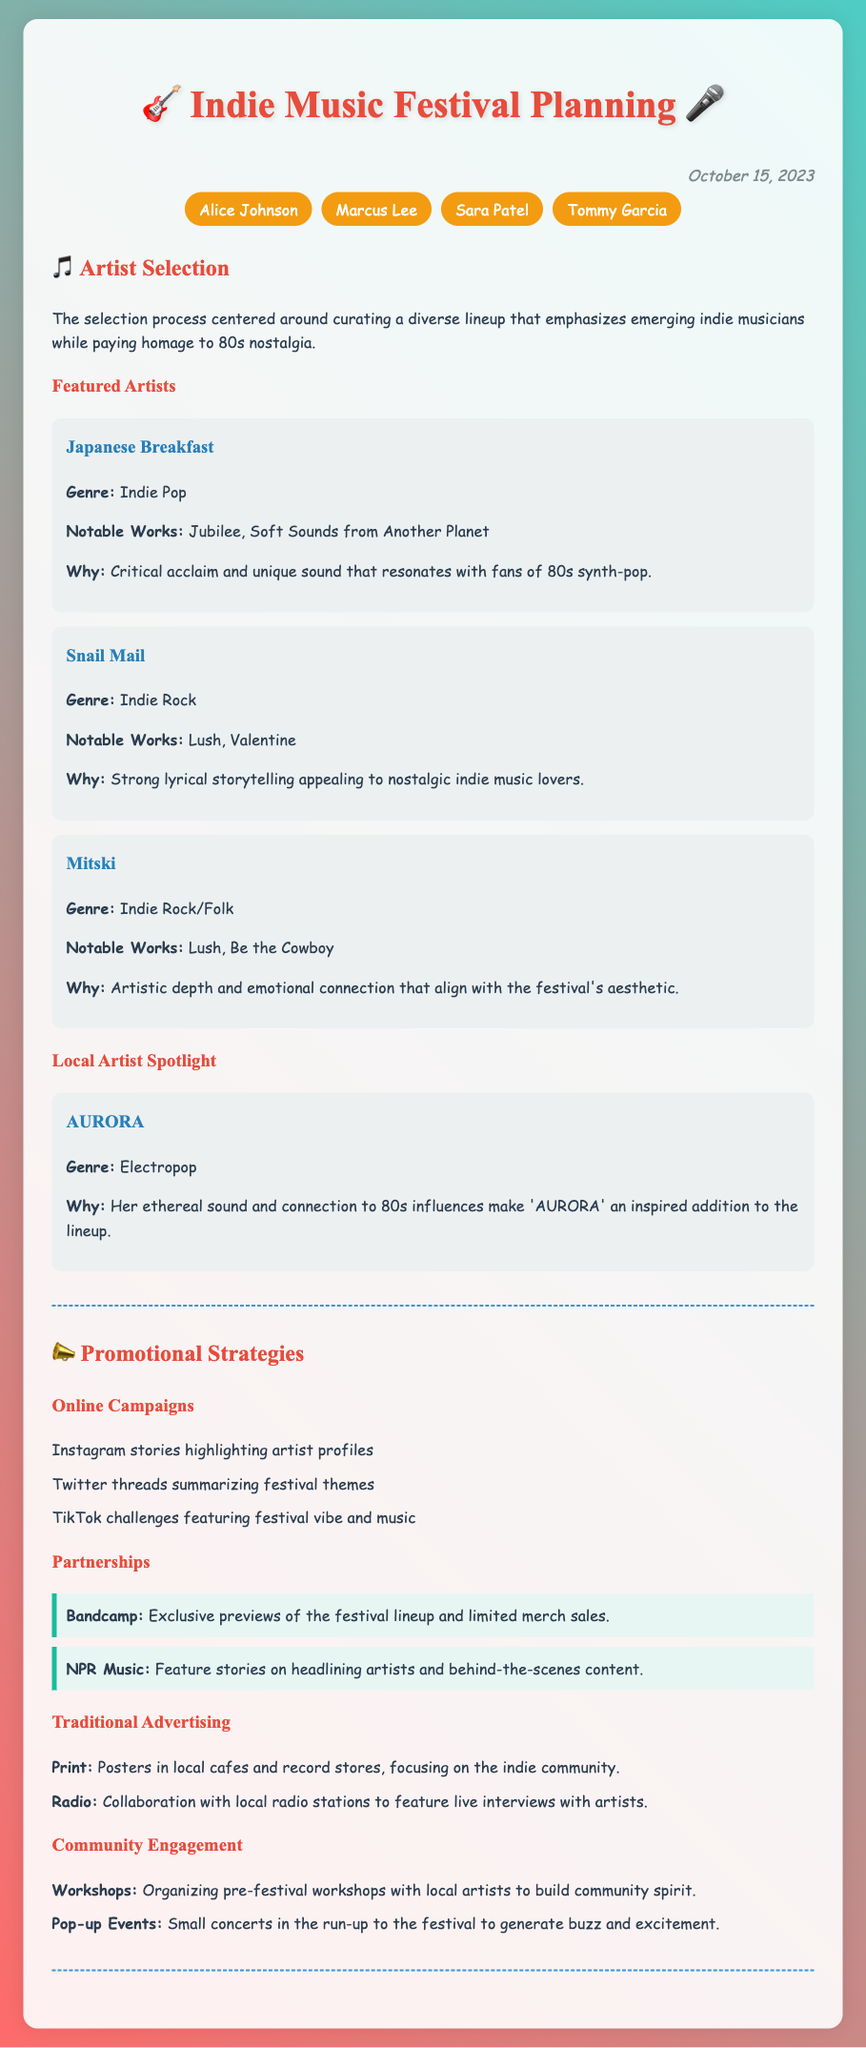what date was the meeting held? The date of the meeting is mentioned at the top of the document as October 15, 2023.
Answer: October 15, 2023 who is one of the featured artists mentioned? The featured artists listed under the artist selection section include Japanese Breakfast, Snail Mail, and Mitski.
Answer: Japanese Breakfast which genre does AURORA belong to? The document specifies that AURORA's genre is Electropop.
Answer: Electropop what is one strategy for online promotion? The document lists strategies such as Instagram stories highlighting artist profiles under online campaigns.
Answer: Instagram stories how many attendees were present at the meeting? The document lists the names of the attendees, which are four in total: Alice Johnson, Marcus Lee, Sara Patel, and Tommy Garcia.
Answer: Four what is one partnership mentioned for promotional strategies? The document refers to partnerships with Bandcamp and NPR Music for promotional strategies.
Answer: Bandcamp why was Mitski selected as a featured artist? The document states that Mitski was chosen for her artistic depth and emotional connection that align with the festival's aesthetic.
Answer: Artistic depth and emotional connection what type of advertising includes posters in local cafes? The document classifies this type of advertising under Traditional Advertising, where posters in local cafes are mentioned.
Answer: Traditional Advertising 